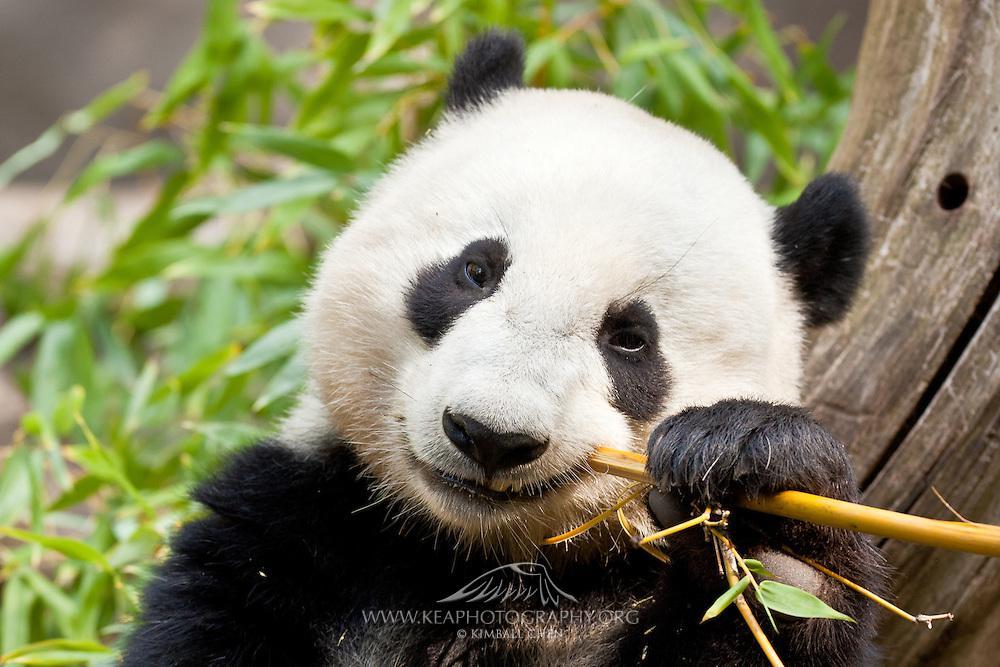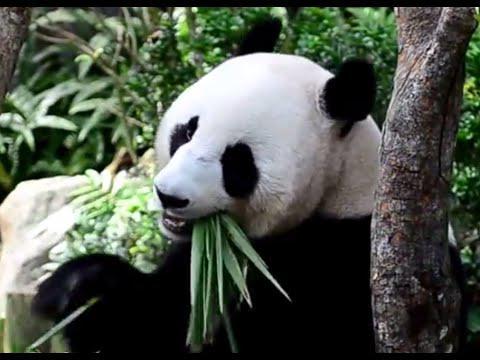The first image is the image on the left, the second image is the image on the right. Given the left and right images, does the statement "One panda is munching a single leafless thick green stalk between his exposed upper and lower teeth." hold true? Answer yes or no. No. 